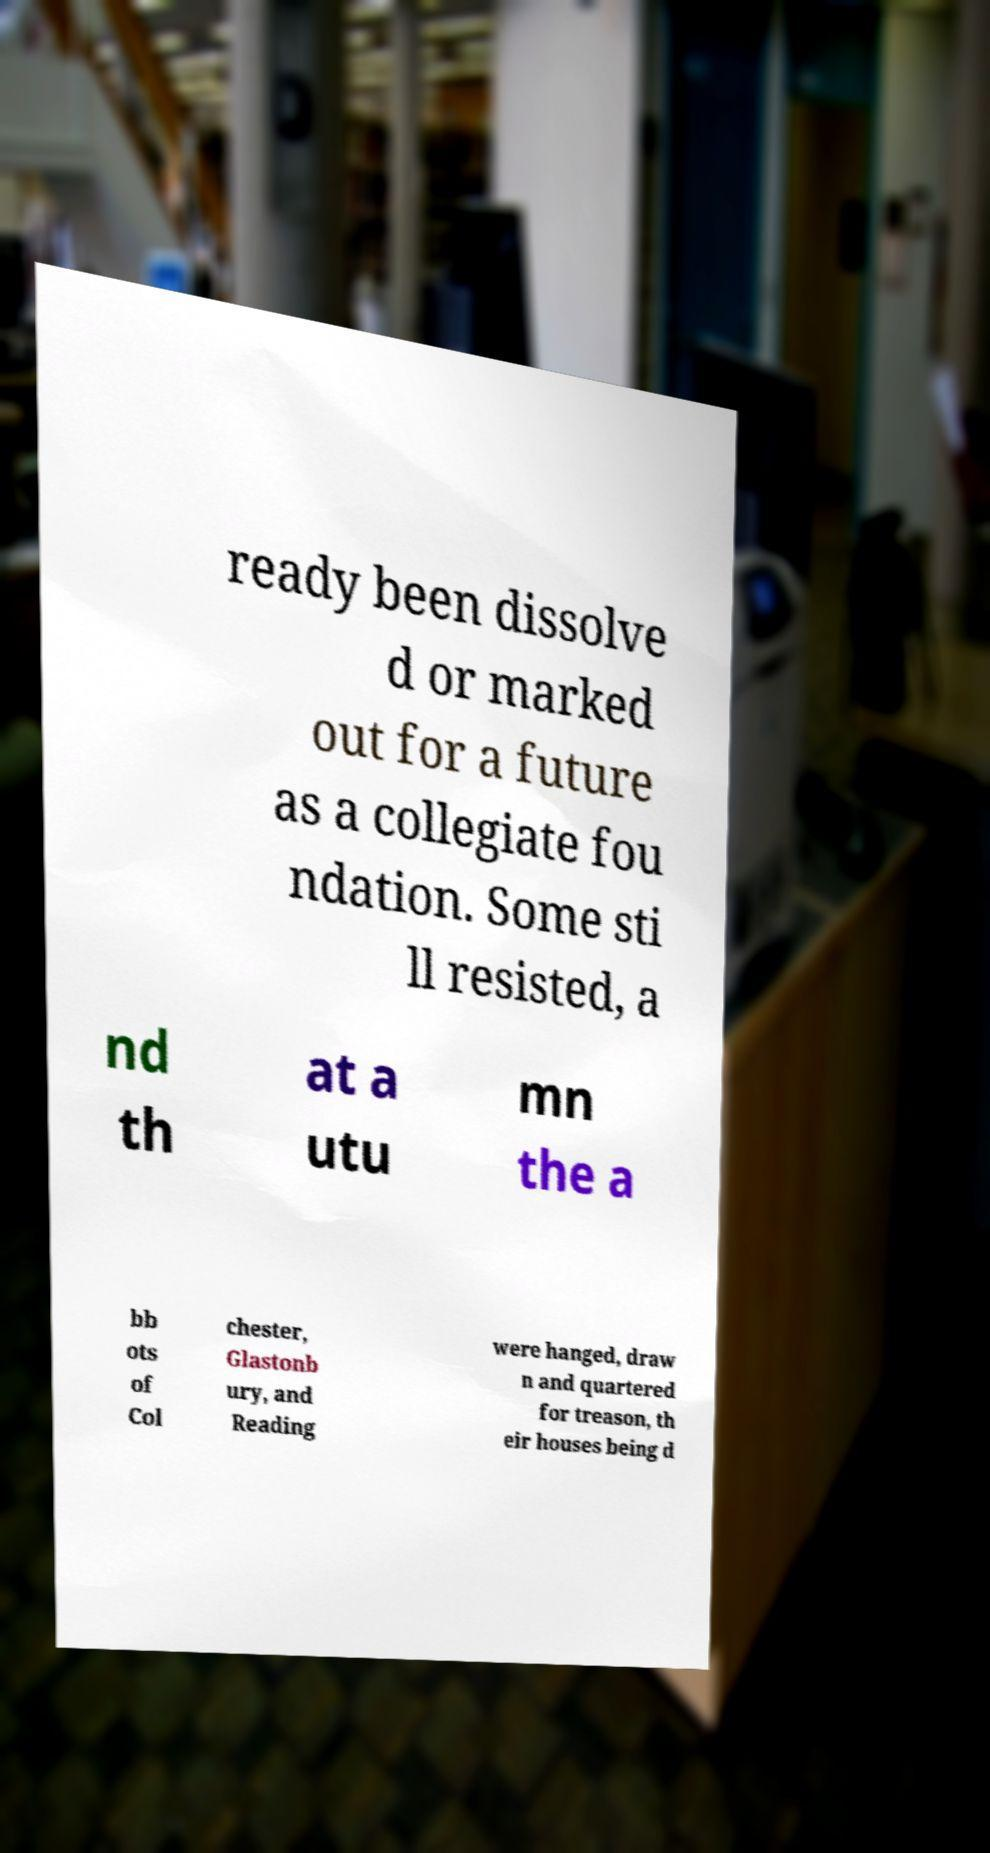Can you read and provide the text displayed in the image?This photo seems to have some interesting text. Can you extract and type it out for me? ready been dissolve d or marked out for a future as a collegiate fou ndation. Some sti ll resisted, a nd th at a utu mn the a bb ots of Col chester, Glastonb ury, and Reading were hanged, draw n and quartered for treason, th eir houses being d 